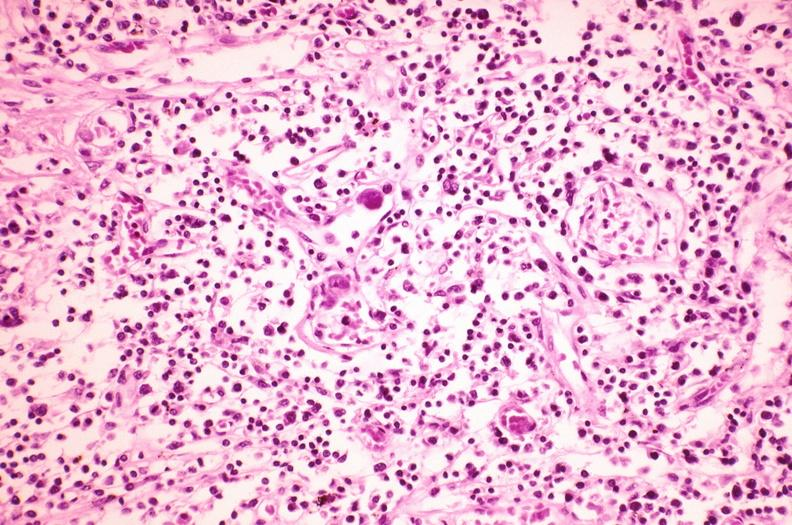does this image show lymph node, cytomegalovirus?
Answer the question using a single word or phrase. Yes 